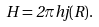<formula> <loc_0><loc_0><loc_500><loc_500>H = 2 \pi h j ( R ) .</formula> 